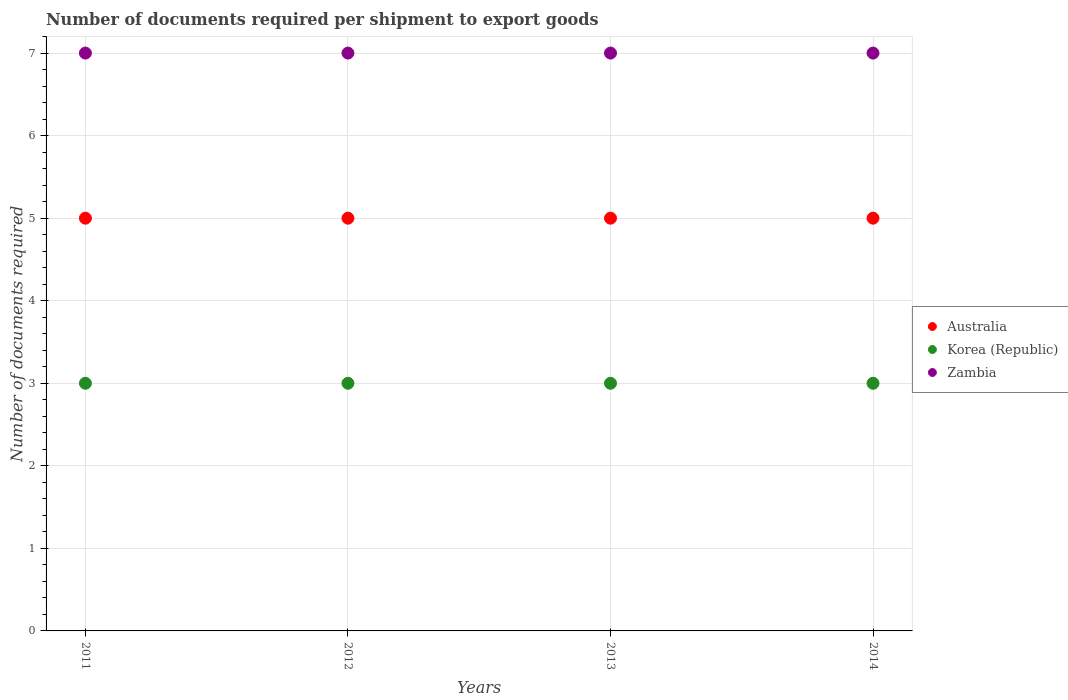How many different coloured dotlines are there?
Offer a terse response. 3. Is the number of dotlines equal to the number of legend labels?
Provide a succinct answer. Yes. What is the number of documents required per shipment to export goods in Australia in 2014?
Provide a short and direct response. 5. Across all years, what is the maximum number of documents required per shipment to export goods in Korea (Republic)?
Your answer should be compact. 3. Across all years, what is the minimum number of documents required per shipment to export goods in Zambia?
Your response must be concise. 7. In which year was the number of documents required per shipment to export goods in Zambia maximum?
Your answer should be compact. 2011. What is the total number of documents required per shipment to export goods in Zambia in the graph?
Give a very brief answer. 28. What is the difference between the number of documents required per shipment to export goods in Australia in 2012 and that in 2013?
Ensure brevity in your answer.  0. What is the difference between the number of documents required per shipment to export goods in Australia in 2013 and the number of documents required per shipment to export goods in Korea (Republic) in 2012?
Offer a terse response. 2. What is the average number of documents required per shipment to export goods in Zambia per year?
Your response must be concise. 7. In the year 2011, what is the difference between the number of documents required per shipment to export goods in Australia and number of documents required per shipment to export goods in Zambia?
Provide a succinct answer. -2. In how many years, is the number of documents required per shipment to export goods in Korea (Republic) greater than 2.6?
Give a very brief answer. 4. Is the number of documents required per shipment to export goods in Australia in 2011 less than that in 2013?
Your answer should be compact. No. Is the difference between the number of documents required per shipment to export goods in Australia in 2012 and 2013 greater than the difference between the number of documents required per shipment to export goods in Zambia in 2012 and 2013?
Give a very brief answer. No. What is the difference between the highest and the second highest number of documents required per shipment to export goods in Australia?
Give a very brief answer. 0. In how many years, is the number of documents required per shipment to export goods in Australia greater than the average number of documents required per shipment to export goods in Australia taken over all years?
Make the answer very short. 0. Is the number of documents required per shipment to export goods in Australia strictly greater than the number of documents required per shipment to export goods in Korea (Republic) over the years?
Your response must be concise. Yes. Is the number of documents required per shipment to export goods in Zambia strictly less than the number of documents required per shipment to export goods in Korea (Republic) over the years?
Make the answer very short. No. How many dotlines are there?
Provide a short and direct response. 3. What is the difference between two consecutive major ticks on the Y-axis?
Offer a very short reply. 1. Are the values on the major ticks of Y-axis written in scientific E-notation?
Make the answer very short. No. Does the graph contain any zero values?
Provide a short and direct response. No. Does the graph contain grids?
Keep it short and to the point. Yes. How many legend labels are there?
Your answer should be very brief. 3. What is the title of the graph?
Keep it short and to the point. Number of documents required per shipment to export goods. What is the label or title of the Y-axis?
Offer a very short reply. Number of documents required. What is the Number of documents required in Korea (Republic) in 2011?
Keep it short and to the point. 3. What is the Number of documents required in Australia in 2012?
Your answer should be compact. 5. What is the Number of documents required in Zambia in 2013?
Offer a terse response. 7. What is the Number of documents required in Korea (Republic) in 2014?
Your answer should be compact. 3. Across all years, what is the maximum Number of documents required in Korea (Republic)?
Provide a succinct answer. 3. Across all years, what is the maximum Number of documents required in Zambia?
Give a very brief answer. 7. Across all years, what is the minimum Number of documents required in Australia?
Make the answer very short. 5. Across all years, what is the minimum Number of documents required of Zambia?
Your response must be concise. 7. What is the total Number of documents required in Korea (Republic) in the graph?
Give a very brief answer. 12. What is the total Number of documents required in Zambia in the graph?
Your response must be concise. 28. What is the difference between the Number of documents required in Korea (Republic) in 2011 and that in 2012?
Give a very brief answer. 0. What is the difference between the Number of documents required of Korea (Republic) in 2011 and that in 2013?
Provide a succinct answer. 0. What is the difference between the Number of documents required of Australia in 2011 and that in 2014?
Make the answer very short. 0. What is the difference between the Number of documents required in Zambia in 2011 and that in 2014?
Offer a very short reply. 0. What is the difference between the Number of documents required of Australia in 2012 and that in 2013?
Your response must be concise. 0. What is the difference between the Number of documents required of Korea (Republic) in 2012 and that in 2013?
Your answer should be very brief. 0. What is the difference between the Number of documents required of Australia in 2012 and that in 2014?
Your response must be concise. 0. What is the difference between the Number of documents required of Korea (Republic) in 2012 and that in 2014?
Offer a very short reply. 0. What is the difference between the Number of documents required of Zambia in 2012 and that in 2014?
Provide a succinct answer. 0. What is the difference between the Number of documents required in Australia in 2013 and that in 2014?
Give a very brief answer. 0. What is the difference between the Number of documents required in Australia in 2011 and the Number of documents required in Korea (Republic) in 2013?
Give a very brief answer. 2. What is the difference between the Number of documents required in Korea (Republic) in 2011 and the Number of documents required in Zambia in 2013?
Your answer should be very brief. -4. What is the difference between the Number of documents required of Australia in 2011 and the Number of documents required of Zambia in 2014?
Offer a terse response. -2. What is the difference between the Number of documents required in Korea (Republic) in 2011 and the Number of documents required in Zambia in 2014?
Your response must be concise. -4. What is the difference between the Number of documents required of Australia in 2012 and the Number of documents required of Zambia in 2013?
Provide a short and direct response. -2. What is the difference between the Number of documents required of Korea (Republic) in 2012 and the Number of documents required of Zambia in 2014?
Provide a short and direct response. -4. What is the difference between the Number of documents required in Australia in 2013 and the Number of documents required in Korea (Republic) in 2014?
Provide a short and direct response. 2. What is the difference between the Number of documents required in Australia in 2013 and the Number of documents required in Zambia in 2014?
Give a very brief answer. -2. What is the average Number of documents required of Australia per year?
Your answer should be compact. 5. What is the average Number of documents required in Korea (Republic) per year?
Make the answer very short. 3. What is the average Number of documents required of Zambia per year?
Offer a terse response. 7. In the year 2012, what is the difference between the Number of documents required of Korea (Republic) and Number of documents required of Zambia?
Give a very brief answer. -4. In the year 2013, what is the difference between the Number of documents required in Korea (Republic) and Number of documents required in Zambia?
Your answer should be very brief. -4. In the year 2014, what is the difference between the Number of documents required in Australia and Number of documents required in Korea (Republic)?
Offer a very short reply. 2. What is the ratio of the Number of documents required of Australia in 2011 to that in 2012?
Your answer should be compact. 1. What is the ratio of the Number of documents required in Zambia in 2011 to that in 2012?
Your answer should be very brief. 1. What is the ratio of the Number of documents required in Zambia in 2011 to that in 2013?
Make the answer very short. 1. What is the ratio of the Number of documents required in Australia in 2011 to that in 2014?
Your answer should be very brief. 1. What is the ratio of the Number of documents required in Zambia in 2011 to that in 2014?
Make the answer very short. 1. What is the ratio of the Number of documents required in Zambia in 2012 to that in 2013?
Ensure brevity in your answer.  1. What is the ratio of the Number of documents required of Zambia in 2012 to that in 2014?
Provide a succinct answer. 1. What is the difference between the highest and the lowest Number of documents required in Australia?
Make the answer very short. 0. What is the difference between the highest and the lowest Number of documents required of Korea (Republic)?
Provide a short and direct response. 0. 